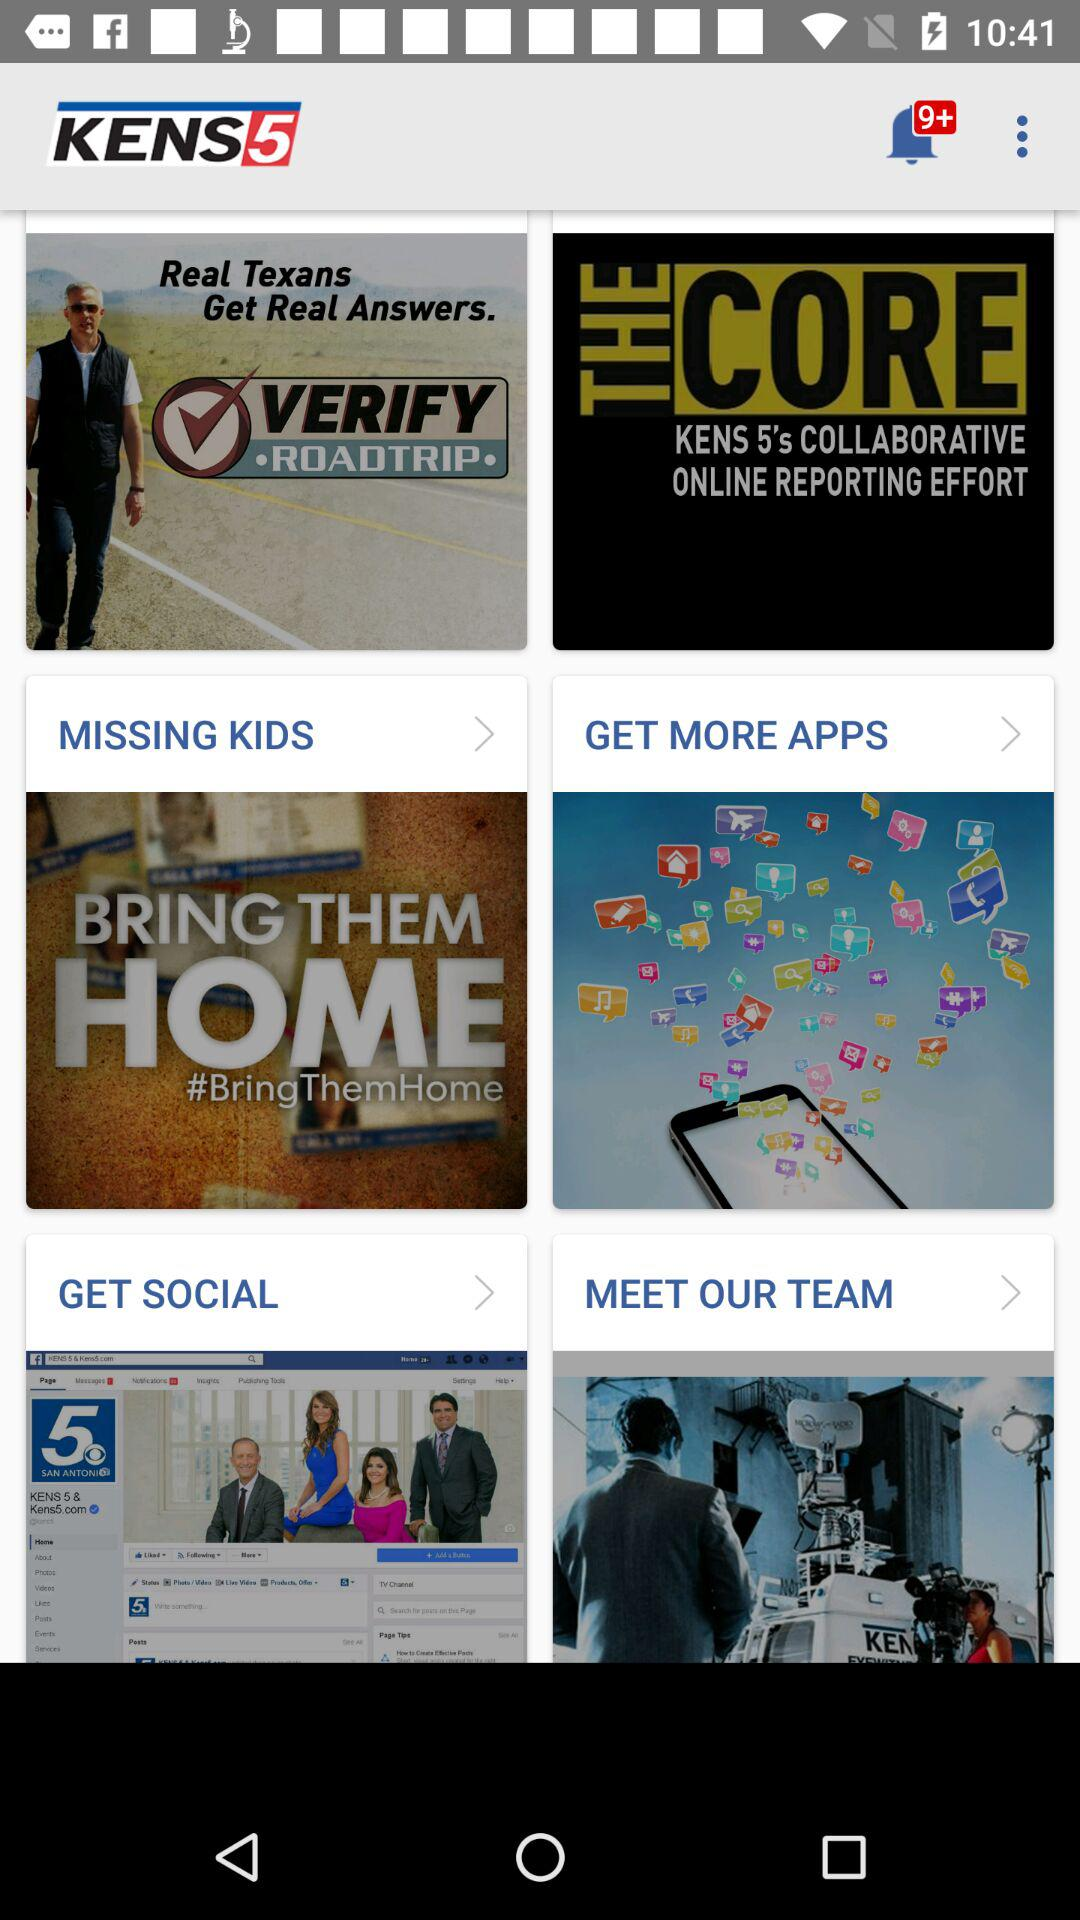How many unread notifications are there? There are more than 9 unread notifications. 